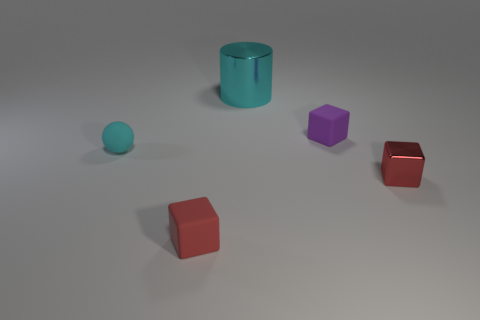There is a object that is the same color as the sphere; what material is it?
Provide a short and direct response. Metal. Does the metal cylinder have the same color as the sphere?
Your answer should be very brief. Yes. Does the cyan object that is in front of the cylinder have the same size as the large cylinder?
Offer a terse response. No. Is there anything else that has the same shape as the cyan shiny thing?
Your answer should be very brief. No. Is the tiny cyan object made of the same material as the tiny red block in front of the tiny metal cube?
Your response must be concise. Yes. How many cyan things are either tiny blocks or tiny spheres?
Make the answer very short. 1. Are any red things visible?
Offer a very short reply. Yes. Is there a small purple thing that is left of the tiny red cube in front of the metallic thing that is on the right side of the cyan cylinder?
Offer a very short reply. No. Is there any other thing that has the same size as the metallic cylinder?
Provide a succinct answer. No. There is a tiny purple object; does it have the same shape as the small rubber thing in front of the tiny cyan matte thing?
Provide a short and direct response. Yes. 